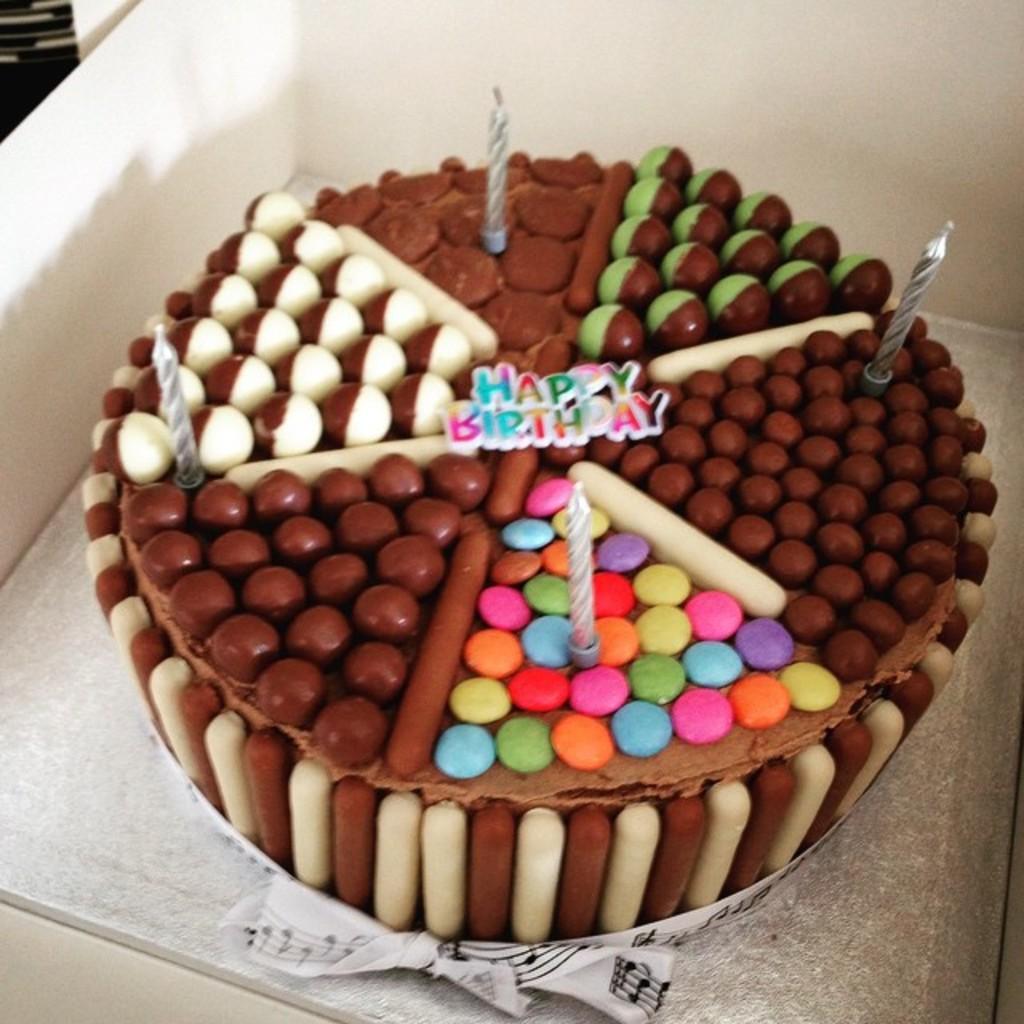How would you summarize this image in a sentence or two? In front of the mage there is a box. Inside the box there is a cake with candles on it. 